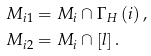Convert formula to latex. <formula><loc_0><loc_0><loc_500><loc_500>M _ { i 1 } & = M _ { i } \cap \Gamma _ { H } \left ( i \right ) , \\ M _ { i 2 } & = M _ { i } \cap \left [ l \right ] .</formula> 